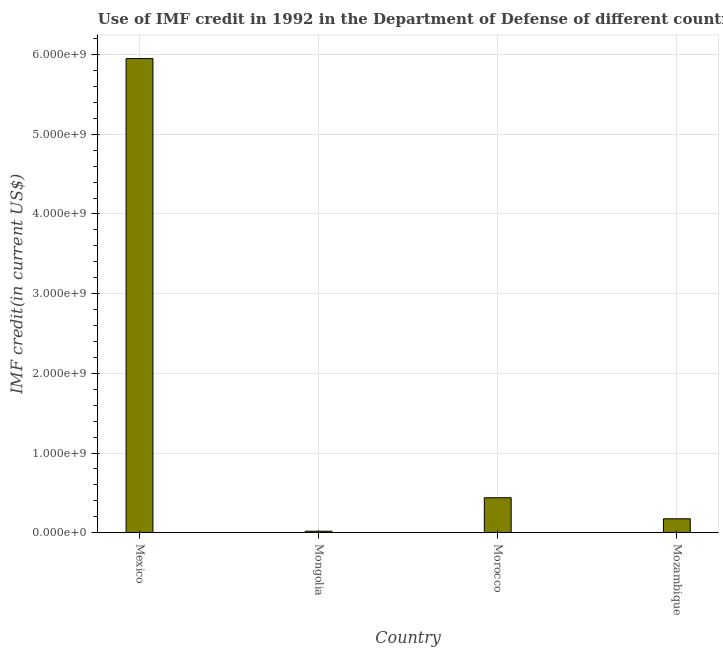Does the graph contain any zero values?
Your answer should be very brief. No. What is the title of the graph?
Provide a succinct answer. Use of IMF credit in 1992 in the Department of Defense of different countries. What is the label or title of the X-axis?
Your response must be concise. Country. What is the label or title of the Y-axis?
Provide a short and direct response. IMF credit(in current US$). What is the use of imf credit in dod in Mongolia?
Provide a succinct answer. 1.89e+07. Across all countries, what is the maximum use of imf credit in dod?
Provide a succinct answer. 5.95e+09. Across all countries, what is the minimum use of imf credit in dod?
Offer a very short reply. 1.89e+07. In which country was the use of imf credit in dod maximum?
Offer a terse response. Mexico. In which country was the use of imf credit in dod minimum?
Give a very brief answer. Mongolia. What is the sum of the use of imf credit in dod?
Offer a very short reply. 6.58e+09. What is the difference between the use of imf credit in dod in Mexico and Mongolia?
Give a very brief answer. 5.93e+09. What is the average use of imf credit in dod per country?
Ensure brevity in your answer.  1.65e+09. What is the median use of imf credit in dod?
Your answer should be very brief. 3.07e+08. In how many countries, is the use of imf credit in dod greater than 5000000000 US$?
Make the answer very short. 1. What is the ratio of the use of imf credit in dod in Mongolia to that in Mozambique?
Make the answer very short. 0.11. Is the use of imf credit in dod in Mexico less than that in Morocco?
Keep it short and to the point. No. What is the difference between the highest and the second highest use of imf credit in dod?
Your answer should be very brief. 5.51e+09. What is the difference between the highest and the lowest use of imf credit in dod?
Offer a very short reply. 5.93e+09. In how many countries, is the use of imf credit in dod greater than the average use of imf credit in dod taken over all countries?
Your answer should be compact. 1. Are all the bars in the graph horizontal?
Your answer should be very brief. No. Are the values on the major ticks of Y-axis written in scientific E-notation?
Provide a short and direct response. Yes. What is the IMF credit(in current US$) in Mexico?
Your answer should be very brief. 5.95e+09. What is the IMF credit(in current US$) of Mongolia?
Offer a very short reply. 1.89e+07. What is the IMF credit(in current US$) in Morocco?
Your response must be concise. 4.39e+08. What is the IMF credit(in current US$) in Mozambique?
Offer a very short reply. 1.74e+08. What is the difference between the IMF credit(in current US$) in Mexico and Mongolia?
Provide a short and direct response. 5.93e+09. What is the difference between the IMF credit(in current US$) in Mexico and Morocco?
Offer a very short reply. 5.51e+09. What is the difference between the IMF credit(in current US$) in Mexico and Mozambique?
Give a very brief answer. 5.78e+09. What is the difference between the IMF credit(in current US$) in Mongolia and Morocco?
Your answer should be compact. -4.20e+08. What is the difference between the IMF credit(in current US$) in Mongolia and Mozambique?
Give a very brief answer. -1.56e+08. What is the difference between the IMF credit(in current US$) in Morocco and Mozambique?
Provide a succinct answer. 2.64e+08. What is the ratio of the IMF credit(in current US$) in Mexico to that in Mongolia?
Make the answer very short. 314.69. What is the ratio of the IMF credit(in current US$) in Mexico to that in Morocco?
Your answer should be very brief. 13.56. What is the ratio of the IMF credit(in current US$) in Mexico to that in Mozambique?
Keep it short and to the point. 34.1. What is the ratio of the IMF credit(in current US$) in Mongolia to that in Morocco?
Offer a terse response. 0.04. What is the ratio of the IMF credit(in current US$) in Mongolia to that in Mozambique?
Your answer should be very brief. 0.11. What is the ratio of the IMF credit(in current US$) in Morocco to that in Mozambique?
Keep it short and to the point. 2.52. 